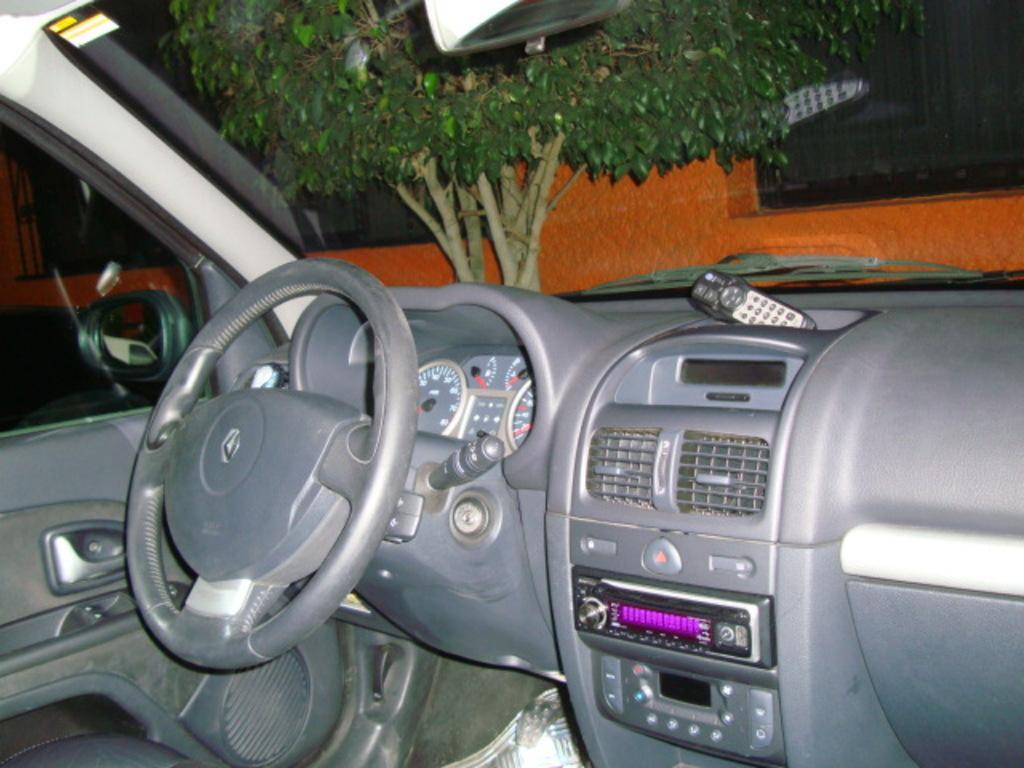Describe this image in one or two sentences. In this picture we can see inside of a vehicle, here we can see a steering, speedometers, remote, mirrors, windscreen wiper and some objects, from windscreen wiper we can see a wall with windows and trees. 